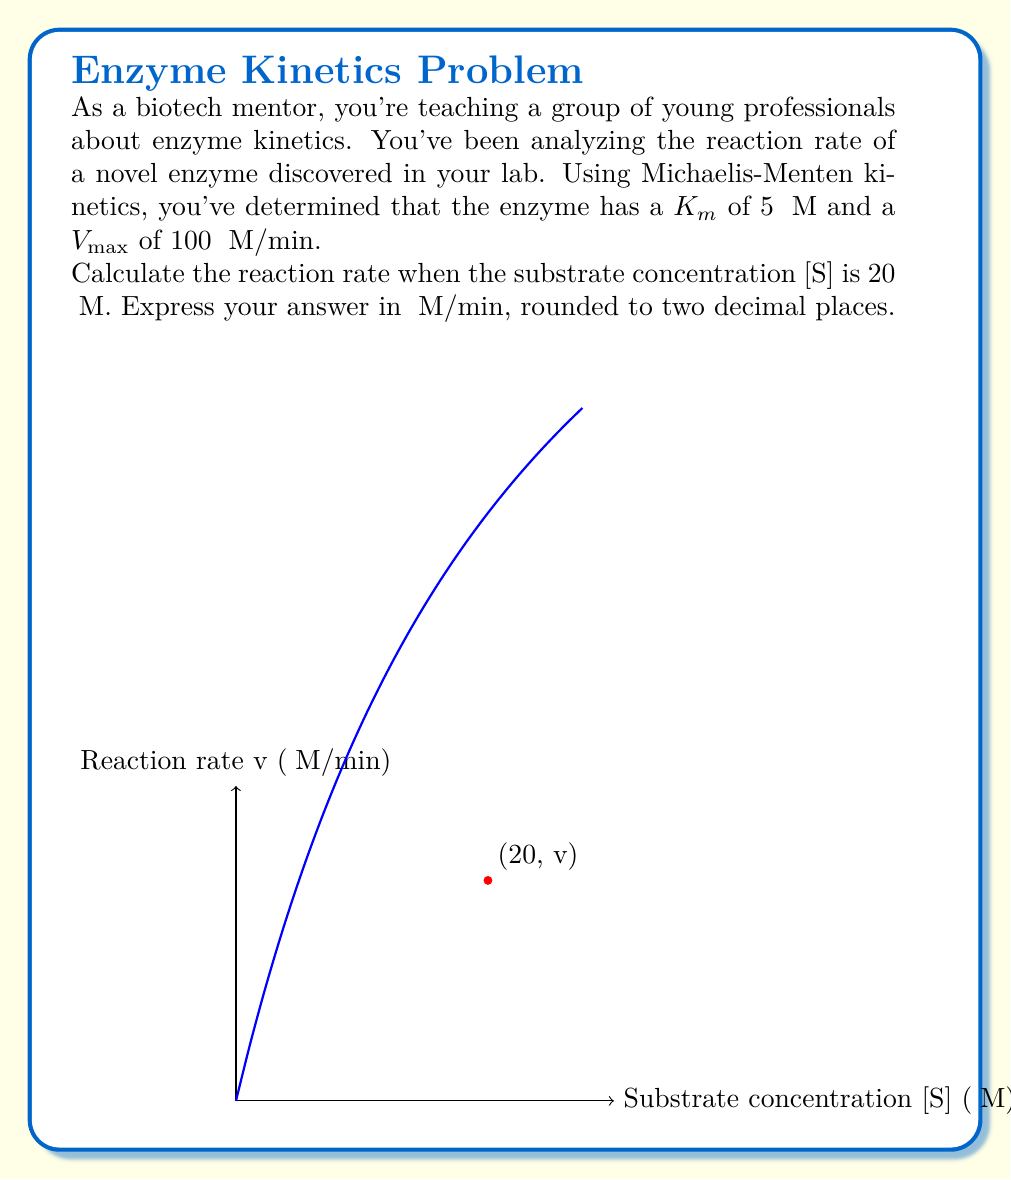Provide a solution to this math problem. Let's approach this step-by-step using the Michaelis-Menten equation:

1) The Michaelis-Menten equation is:

   $$v = \frac{V_{max}[S]}{K_m + [S]}$$

   Where:
   $v$ is the reaction rate
   $V_{max}$ is the maximum reaction rate
   $[S]$ is the substrate concentration
   $K_m$ is the Michaelis constant

2) We are given:
   $V_{max} = 100$ μM/min
   $K_m = 5$ μM
   $[S] = 20$ μM

3) Let's substitute these values into the equation:

   $$v = \frac{100 \cdot 20}{5 + 20}$$

4) Simplify:
   $$v = \frac{2000}{25}$$

5) Calculate:
   $$v = 80$$ μM/min

Therefore, the reaction rate when [S] = 20 μM is 80 μM/min.
Answer: 80 μM/min 